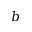<formula> <loc_0><loc_0><loc_500><loc_500>b</formula> 